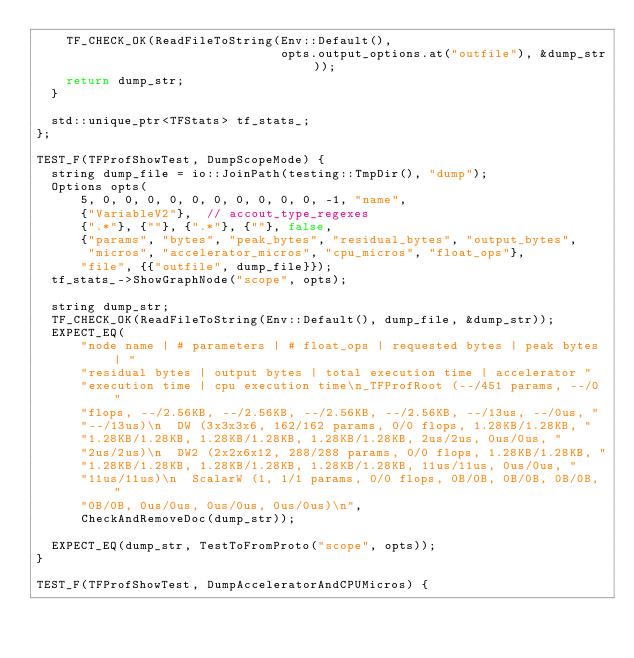<code> <loc_0><loc_0><loc_500><loc_500><_C++_>    TF_CHECK_OK(ReadFileToString(Env::Default(),
                                 opts.output_options.at("outfile"), &dump_str));
    return dump_str;
  }

  std::unique_ptr<TFStats> tf_stats_;
};

TEST_F(TFProfShowTest, DumpScopeMode) {
  string dump_file = io::JoinPath(testing::TmpDir(), "dump");
  Options opts(
      5, 0, 0, 0, 0, 0, 0, 0, 0, 0, 0, -1, "name",
      {"VariableV2"},  // accout_type_regexes
      {".*"}, {""}, {".*"}, {""}, false,
      {"params", "bytes", "peak_bytes", "residual_bytes", "output_bytes",
       "micros", "accelerator_micros", "cpu_micros", "float_ops"},
      "file", {{"outfile", dump_file}});
  tf_stats_->ShowGraphNode("scope", opts);

  string dump_str;
  TF_CHECK_OK(ReadFileToString(Env::Default(), dump_file, &dump_str));
  EXPECT_EQ(
      "node name | # parameters | # float_ops | requested bytes | peak bytes | "
      "residual bytes | output bytes | total execution time | accelerator "
      "execution time | cpu execution time\n_TFProfRoot (--/451 params, --/0 "
      "flops, --/2.56KB, --/2.56KB, --/2.56KB, --/2.56KB, --/13us, --/0us, "
      "--/13us)\n  DW (3x3x3x6, 162/162 params, 0/0 flops, 1.28KB/1.28KB, "
      "1.28KB/1.28KB, 1.28KB/1.28KB, 1.28KB/1.28KB, 2us/2us, 0us/0us, "
      "2us/2us)\n  DW2 (2x2x6x12, 288/288 params, 0/0 flops, 1.28KB/1.28KB, "
      "1.28KB/1.28KB, 1.28KB/1.28KB, 1.28KB/1.28KB, 11us/11us, 0us/0us, "
      "11us/11us)\n  ScalarW (1, 1/1 params, 0/0 flops, 0B/0B, 0B/0B, 0B/0B, "
      "0B/0B, 0us/0us, 0us/0us, 0us/0us)\n",
      CheckAndRemoveDoc(dump_str));

  EXPECT_EQ(dump_str, TestToFromProto("scope", opts));
}

TEST_F(TFProfShowTest, DumpAcceleratorAndCPUMicros) {</code> 